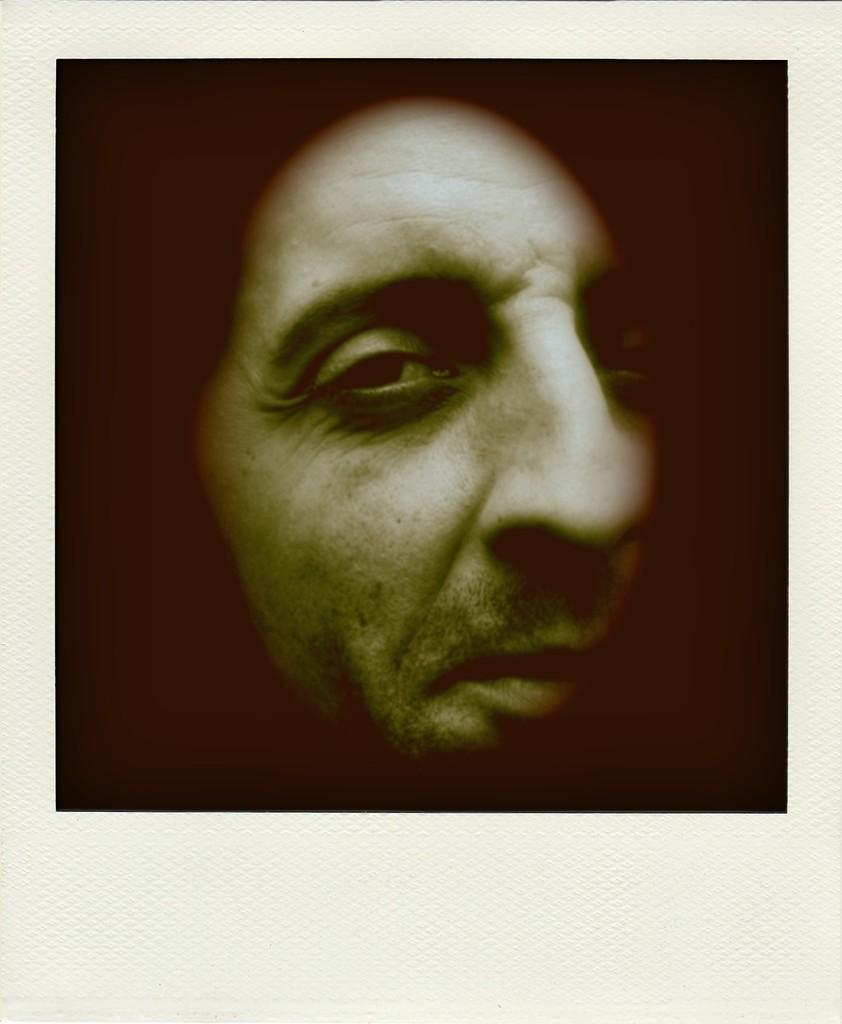What is the main subject of the image? There is a person's face in the image. Can you describe the background of the image? The background of the image is dark. What type of apparatus is being used by the person in the image? There is no apparatus visible in the image; it only shows a person's face. What time of day is depicted in the image? The time of day cannot be determined from the image, as there is no indication of the time. 